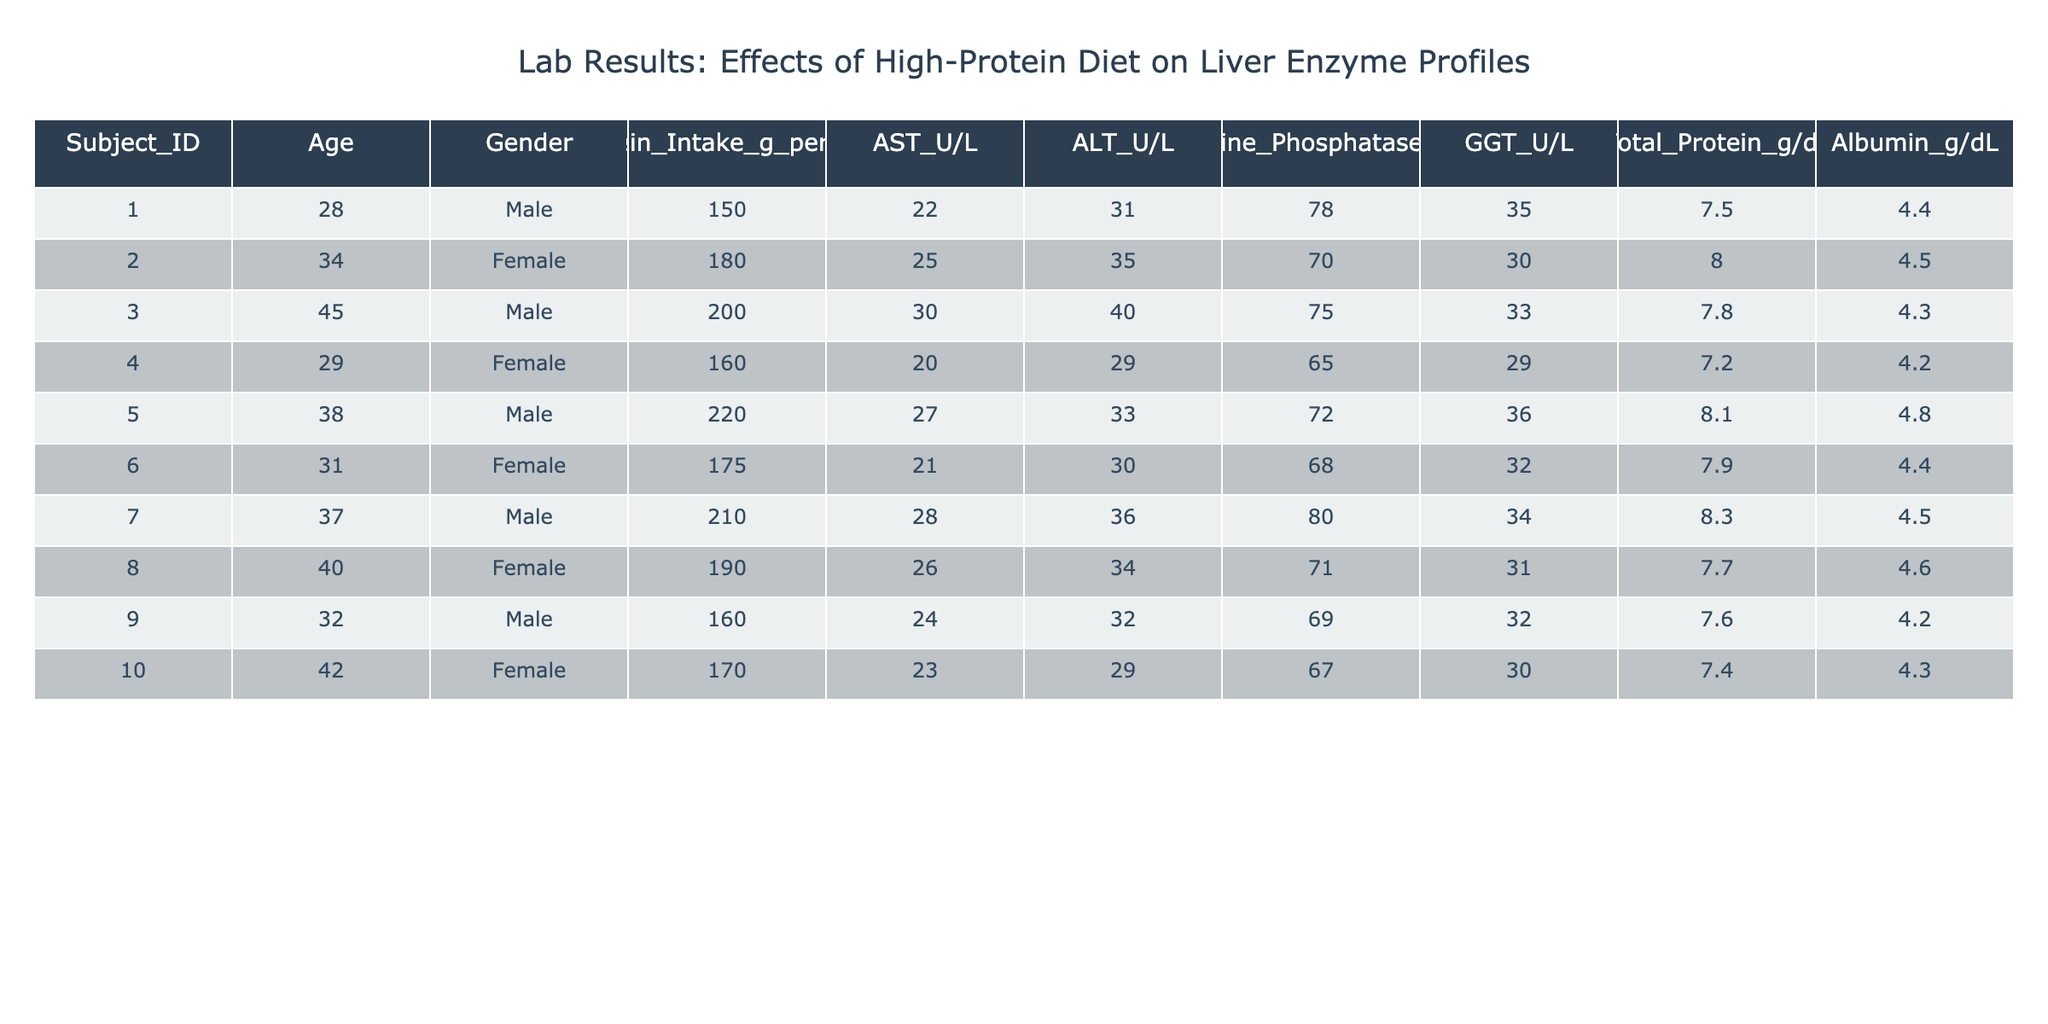What is the AST level for the subject with the highest protein intake? The subject with the highest protein intake is Subject_ID 5, who has a protein intake of 220 g per day. Looking at their AST level, it is 27 U/L.
Answer: 27 U/L What is the average ALT level among all subjects? To find the average ALT level, sum all the ALT values: 31 + 35 + 40 + 29 + 33 + 30 + 36 + 34 + 32 + 29 =  359. There are 10 subjects, so the average is 359/10 = 35.9 U/L.
Answer: 35.9 U/L Is there any subject with an Alkaline Phosphatase level higher than 75 U/L? Looking through the Alkaline Phosphatase levels, the maximum value is 80 U/L (for Subject_ID 7). Therefore, there is at least one subject with a level higher than 75 U/L.
Answer: Yes What is the difference in GGT levels between the subject with the highest and the lowest protein intake? The highest protein intake is 220 g per day (Subject_ID 5) with a GGT level of 36 U/L, while the lowest intake is 150 g per day (Subject_ID 1) with a GGT level of 35 U/L. The difference is 36 - 35 = 1 U/L.
Answer: 1 U/L Which gender has the highest average Albumin level? For Male: (4.4 + 4.3 + 4.8 + 4.5 + 4.2) / 5 = 4.44 g/dL. For Female: (4.5 + 4.2 + 4.6 + 4.3) / 4 = 4.4 g/dL. Males have a higher average Albumin level by 0.04 g/dL.
Answer: Male What is the Total Protein level for the youngest subject? The youngest subject is Subject_ID 1, aged 28 years. Their Total Protein level is 7.5 g/dL.
Answer: 7.5 g/dL Among the subjects with protein intake above 200 g per day, which has the highest ALT level? Subjects with protein intake above 200 g are Subject_ID 3 (200 g, ALT 40 U/L), Subject_ID 5 (220 g, ALT 33 U/L), and Subject_ID 7 (210 g, ALT 36 U/L). The highest ALT is 40 U/L from Subject_ID 3.
Answer: Subject_ID 3 What is the median Age of the subjects in the study? When the ages are arranged as 28, 29, 31, 32, 34, 37, 38, 40, 42, 45, the median is the average of the 5th and 6th ages: (34 + 37) / 2 = 35.5 years.
Answer: 35.5 years 